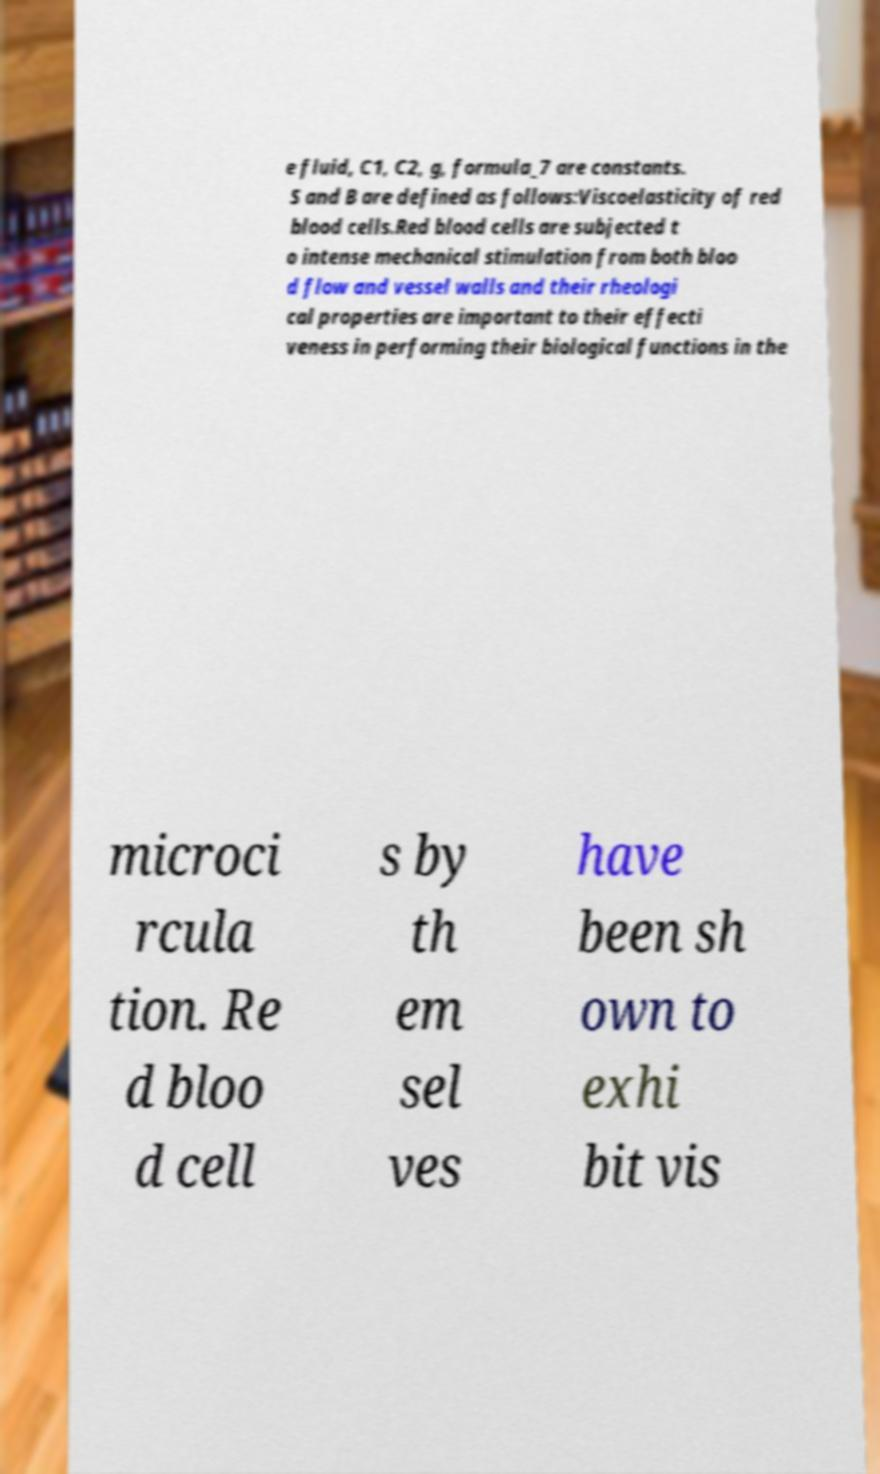Please identify and transcribe the text found in this image. e fluid, C1, C2, g, formula_7 are constants. S and B are defined as follows:Viscoelasticity of red blood cells.Red blood cells are subjected t o intense mechanical stimulation from both bloo d flow and vessel walls and their rheologi cal properties are important to their effecti veness in performing their biological functions in the microci rcula tion. Re d bloo d cell s by th em sel ves have been sh own to exhi bit vis 